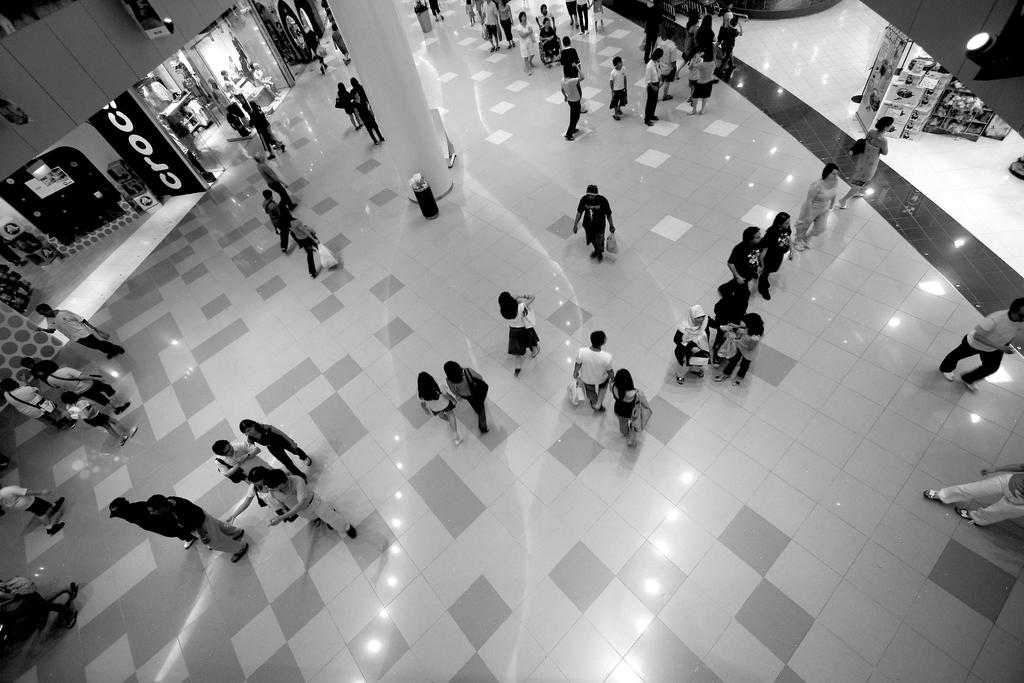What can be seen in the image involving a group of people? There is a group of people in the image. What is located on the left side of the image? There are stores on the left side of the image. What is associated with the stores in the image? There is a board associated with the stores. What architectural feature is visible in the image? There is a pillar visible in the image. Where is the light source located in the image? There is a light in the top right hand side of the image. What type of powder is being used by the group of people in the image? There is no powder being used by the group of people in the image. What rhythm is being played by the stores in the image? There is no rhythm being played by the stores in the image. 